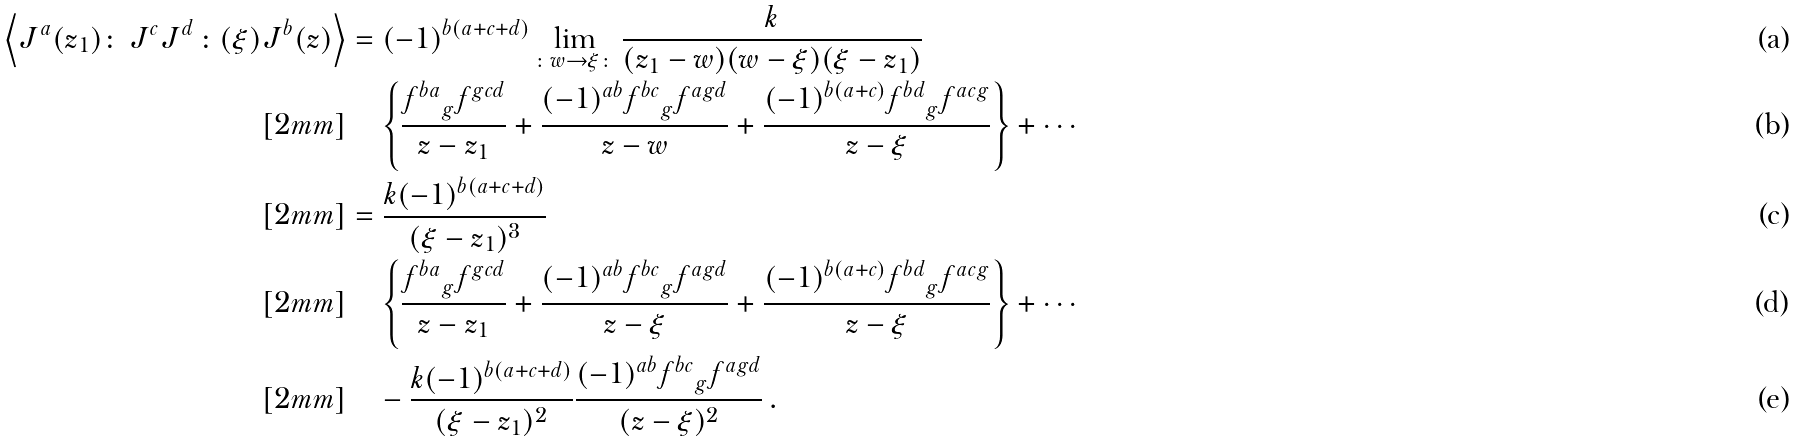Convert formula to latex. <formula><loc_0><loc_0><loc_500><loc_500>\left \langle J ^ { a } ( z _ { 1 } ) \colon \, J ^ { c } J ^ { d } \, \colon ( \xi ) J ^ { b } ( z ) \right \rangle & = ( - 1 ) ^ { b ( a + c + d ) } \lim _ { \colon w \to \xi \colon } \frac { k } { ( z _ { 1 } - w ) ( w - \xi ) ( \xi - z _ { 1 } ) } \\ [ 2 m m ] & \quad \left \{ \frac { { f ^ { b a } } _ { g } f ^ { g c d } } { z - z _ { 1 } } + \frac { ( - 1 ) ^ { a b } { f ^ { b c } } _ { g } f ^ { a g d } } { z - w } + \frac { ( - 1 ) ^ { b ( a + c ) } { f ^ { b d } } _ { g } f ^ { a c g } } { z - \xi } \right \} + \cdots \\ [ 2 m m ] & = \frac { k ( - 1 ) ^ { b ( a + c + d ) } } { ( \xi - z _ { 1 } ) ^ { 3 } } \\ [ 2 m m ] & \quad \left \{ \frac { { f ^ { b a } } _ { g } f ^ { g c d } } { z - z _ { 1 } } + \frac { ( - 1 ) ^ { a b } { f ^ { b c } } _ { g } f ^ { a g d } } { z - \xi } + \frac { ( - 1 ) ^ { b ( a + c ) } { f ^ { b d } } _ { g } f ^ { a c g } } { z - \xi } \right \} + \cdots \\ [ 2 m m ] & \quad - \frac { k ( - 1 ) ^ { b ( a + c + d ) } } { ( \xi - z _ { 1 } ) ^ { 2 } } \frac { ( - 1 ) ^ { a b } { f ^ { b c } } _ { g } f ^ { a g d } } { ( z - \xi ) ^ { 2 } } \, .</formula> 